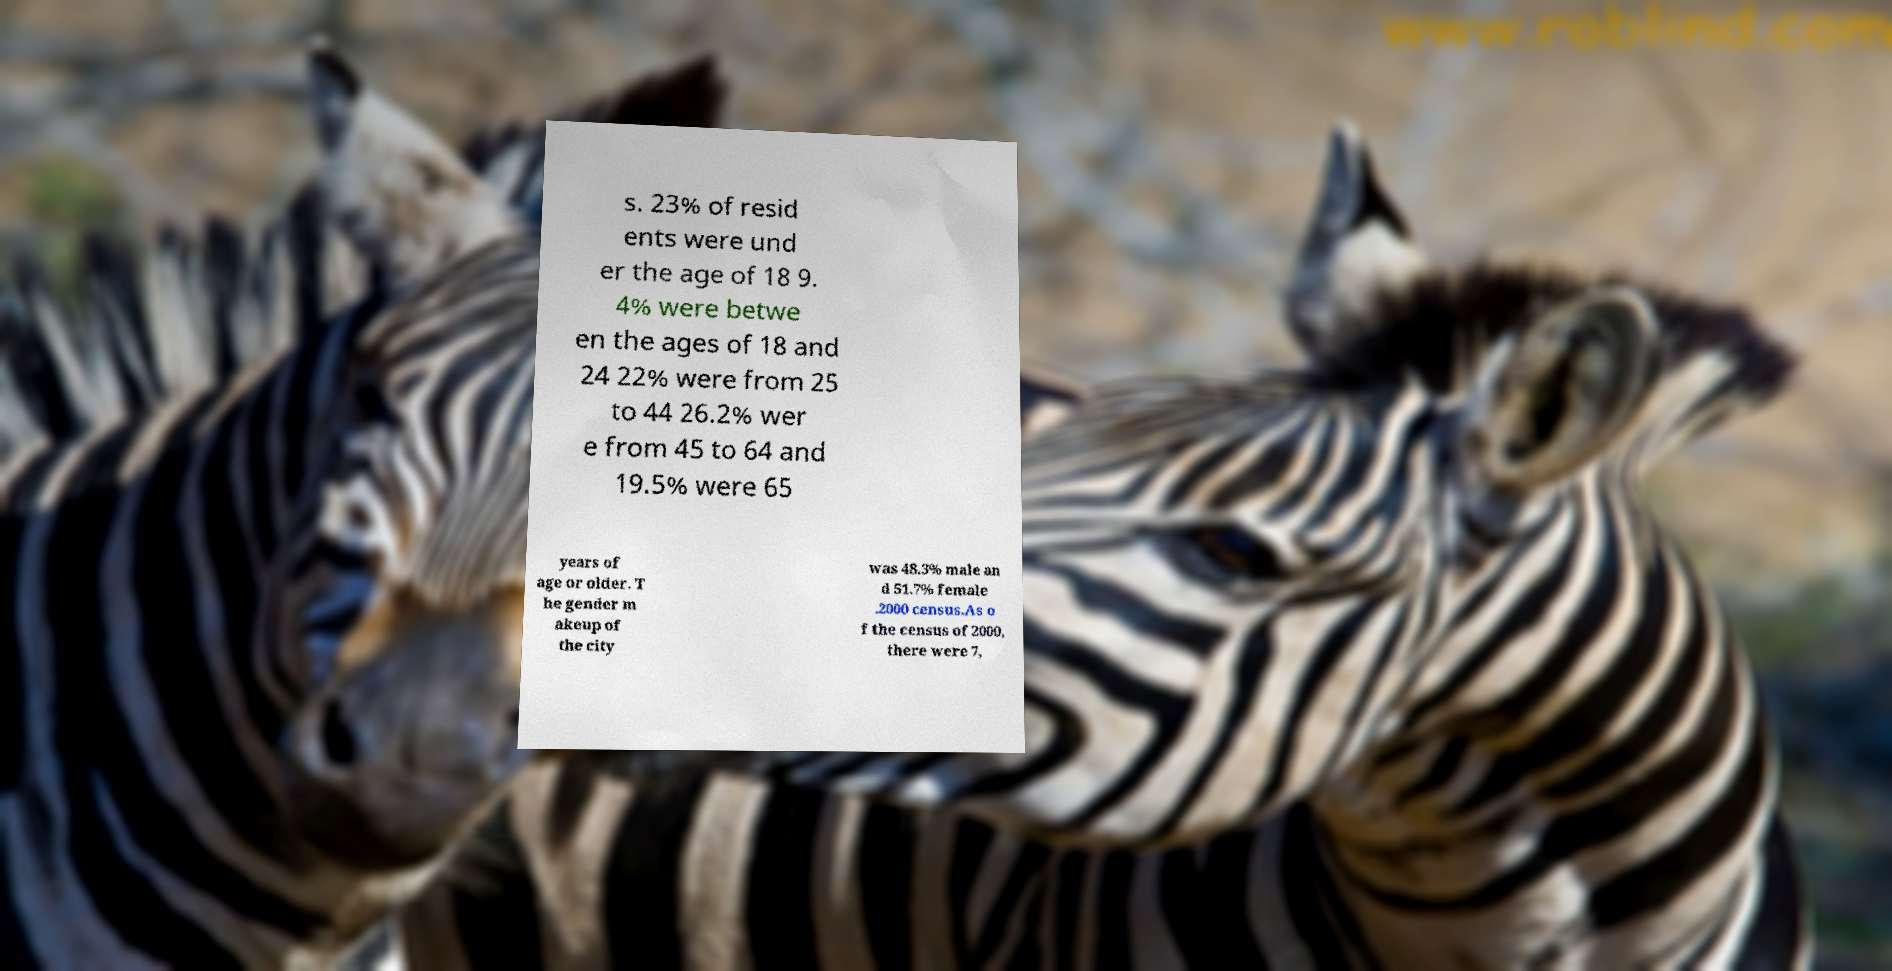For documentation purposes, I need the text within this image transcribed. Could you provide that? s. 23% of resid ents were und er the age of 18 9. 4% were betwe en the ages of 18 and 24 22% were from 25 to 44 26.2% wer e from 45 to 64 and 19.5% were 65 years of age or older. T he gender m akeup of the city was 48.3% male an d 51.7% female .2000 census.As o f the census of 2000, there were 7, 